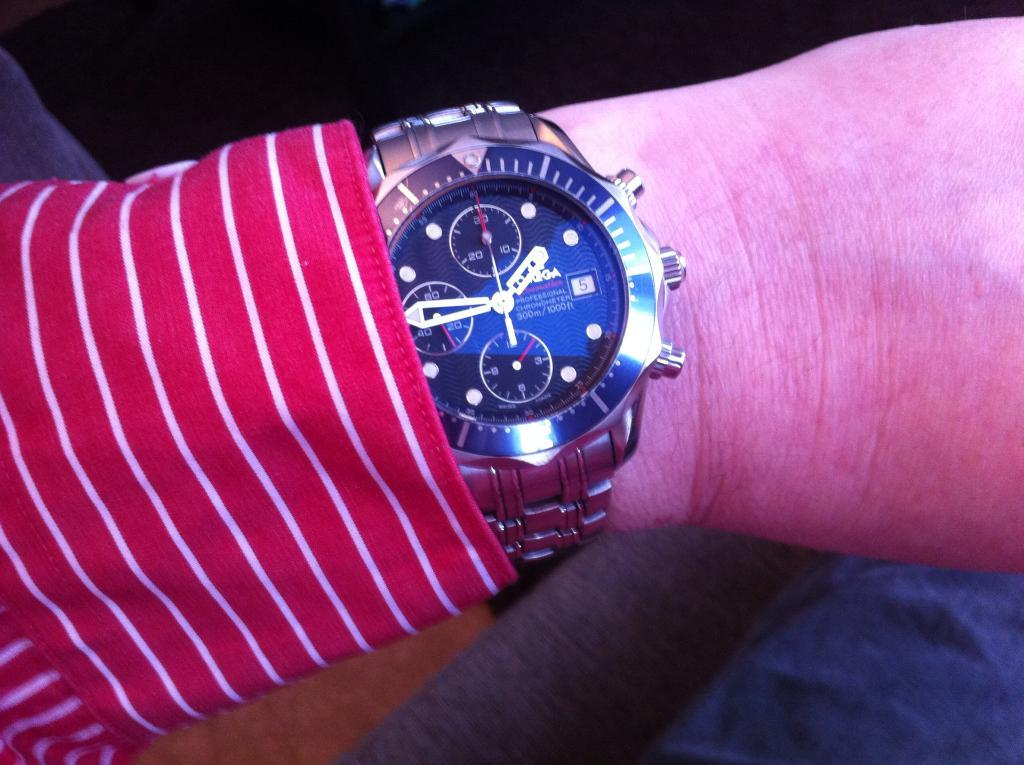<image>
Provide a brief description of the given image. A nice watch that has a silver face and the word professional on it. 